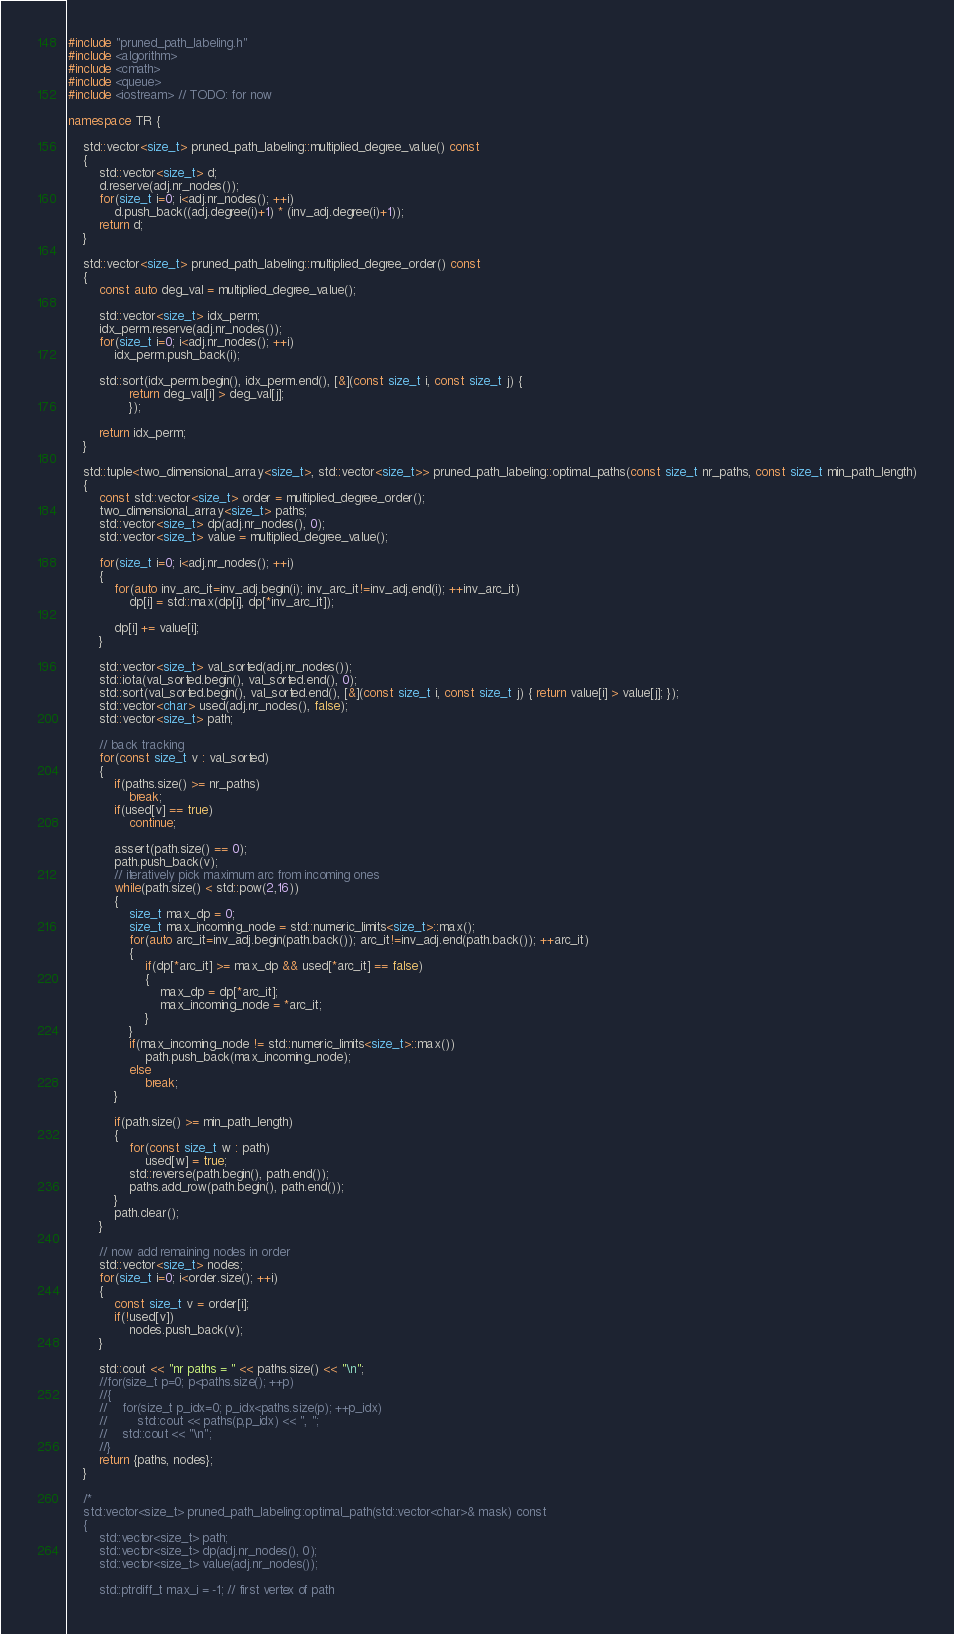<code> <loc_0><loc_0><loc_500><loc_500><_C++_>#include "pruned_path_labeling.h"
#include <algorithm>
#include <cmath>
#include <queue>
#include <iostream> // TODO: for now

namespace TR {

    std::vector<size_t> pruned_path_labeling::multiplied_degree_value() const
    {
        std::vector<size_t> d;
        d.reserve(adj.nr_nodes());
        for(size_t i=0; i<adj.nr_nodes(); ++i)
            d.push_back((adj.degree(i)+1) * (inv_adj.degree(i)+1));
        return d;
    }

    std::vector<size_t> pruned_path_labeling::multiplied_degree_order() const
    {
        const auto deg_val = multiplied_degree_value();

        std::vector<size_t> idx_perm;
        idx_perm.reserve(adj.nr_nodes());
        for(size_t i=0; i<adj.nr_nodes(); ++i)
            idx_perm.push_back(i);

        std::sort(idx_perm.begin(), idx_perm.end(), [&](const size_t i, const size_t j) {
                return deg_val[i] > deg_val[j];
                });

        return idx_perm;
    }

    std::tuple<two_dimensional_array<size_t>, std::vector<size_t>> pruned_path_labeling::optimal_paths(const size_t nr_paths, const size_t min_path_length)
    {
        const std::vector<size_t> order = multiplied_degree_order();
        two_dimensional_array<size_t> paths;
        std::vector<size_t> dp(adj.nr_nodes(), 0);
        std::vector<size_t> value = multiplied_degree_value();

        for(size_t i=0; i<adj.nr_nodes(); ++i)
        {
            for(auto inv_arc_it=inv_adj.begin(i); inv_arc_it!=inv_adj.end(i); ++inv_arc_it)
                dp[i] = std::max(dp[i], dp[*inv_arc_it]);
            
            dp[i] += value[i];
        }

        std::vector<size_t> val_sorted(adj.nr_nodes());
        std::iota(val_sorted.begin(), val_sorted.end(), 0);
        std::sort(val_sorted.begin(), val_sorted.end(), [&](const size_t i, const size_t j) { return value[i] > value[j]; });
        std::vector<char> used(adj.nr_nodes(), false);
        std::vector<size_t> path;

        // back tracking
        for(const size_t v : val_sorted)
        {
            if(paths.size() >= nr_paths)
                break;
            if(used[v] == true)
                continue;

            assert(path.size() == 0);
            path.push_back(v);
            // iteratively pick maximum arc from incoming ones 
            while(path.size() < std::pow(2,16))
            { 
                size_t max_dp = 0;
                size_t max_incoming_node = std::numeric_limits<size_t>::max();
                for(auto arc_it=inv_adj.begin(path.back()); arc_it!=inv_adj.end(path.back()); ++arc_it)
                {
                    if(dp[*arc_it] >= max_dp && used[*arc_it] == false)
                    {
                        max_dp = dp[*arc_it];
                        max_incoming_node = *arc_it;
                    } 
                }
                if(max_incoming_node != std::numeric_limits<size_t>::max())
                    path.push_back(max_incoming_node);
                else
                    break;
            }

            if(path.size() >= min_path_length)
            {
                for(const size_t w : path)
                    used[w] = true;
                std::reverse(path.begin(), path.end());
                paths.add_row(path.begin(), path.end());
            }
            path.clear();
        }

        // now add remaining nodes in order
        std::vector<size_t> nodes;
        for(size_t i=0; i<order.size(); ++i)
        {
            const size_t v = order[i];
            if(!used[v])
                nodes.push_back(v); 
        }

        std::cout << "nr paths = " << paths.size() << "\n";
        //for(size_t p=0; p<paths.size(); ++p)
        //{
        //    for(size_t p_idx=0; p_idx<paths.size(p); ++p_idx)
        //        std::cout << paths(p,p_idx) << ", ";
        //    std::cout << "\n";
        //}
        return {paths, nodes};
    }

    /*
    std::vector<size_t> pruned_path_labeling::optimal_path(std::vector<char>& mask) const
    {
        std::vector<size_t> path;
        std::vector<size_t> dp(adj.nr_nodes(), 0);
        std::vector<size_t> value(adj.nr_nodes());

        std::ptrdiff_t max_i = -1; // first vertex of path</code> 